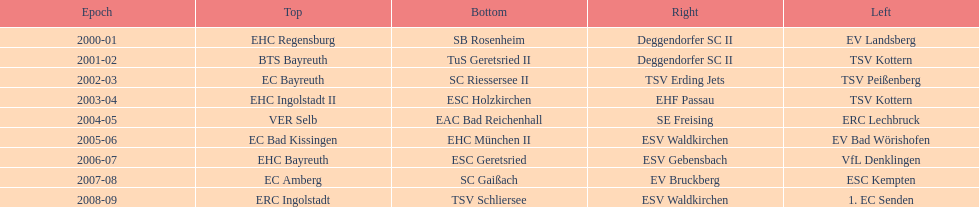The only team to win the north in 2000-01 season? EHC Regensburg. 